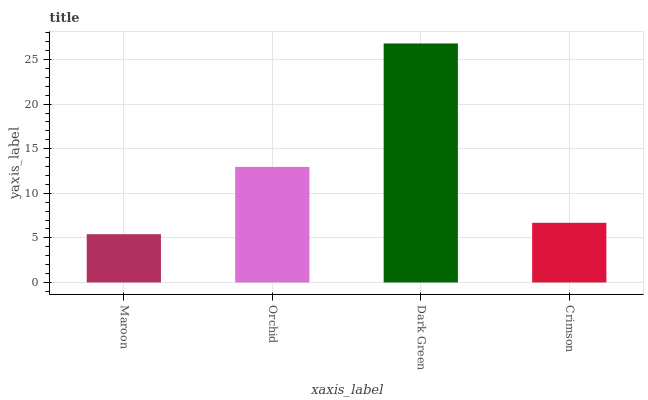Is Maroon the minimum?
Answer yes or no. Yes. Is Dark Green the maximum?
Answer yes or no. Yes. Is Orchid the minimum?
Answer yes or no. No. Is Orchid the maximum?
Answer yes or no. No. Is Orchid greater than Maroon?
Answer yes or no. Yes. Is Maroon less than Orchid?
Answer yes or no. Yes. Is Maroon greater than Orchid?
Answer yes or no. No. Is Orchid less than Maroon?
Answer yes or no. No. Is Orchid the high median?
Answer yes or no. Yes. Is Crimson the low median?
Answer yes or no. Yes. Is Crimson the high median?
Answer yes or no. No. Is Maroon the low median?
Answer yes or no. No. 